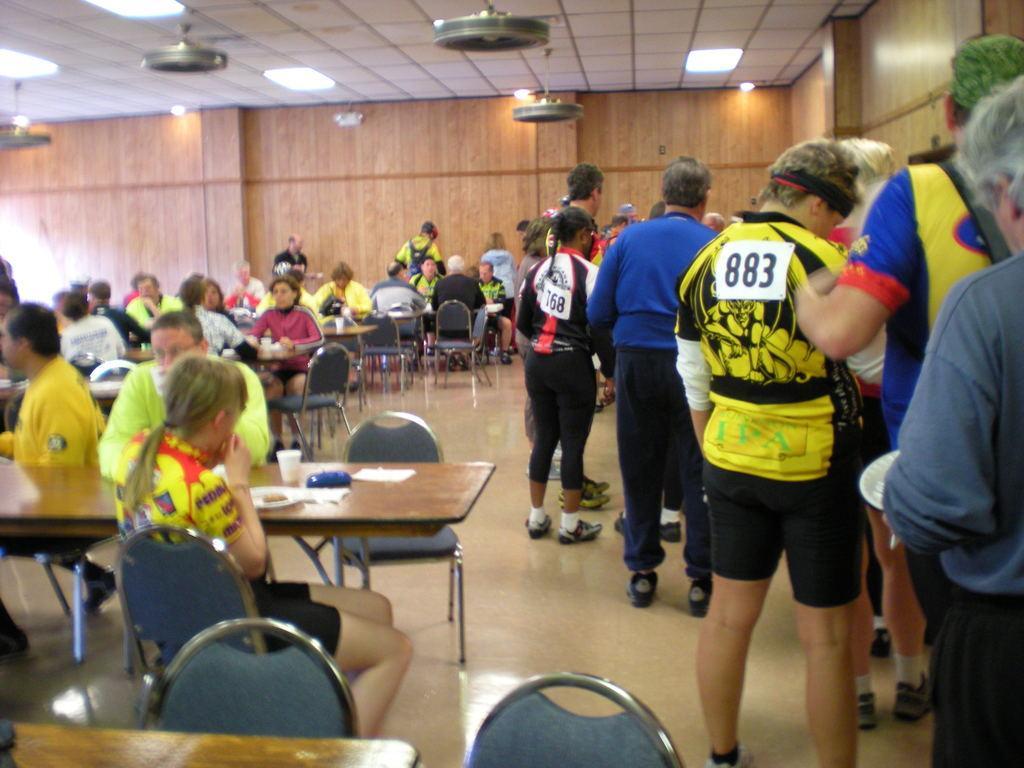Can you describe this image briefly? In this picture many people are sitting. And to the right side there are some people standing. There is a table. On the table there are paper, cups and a plate. On the top there are lights. 